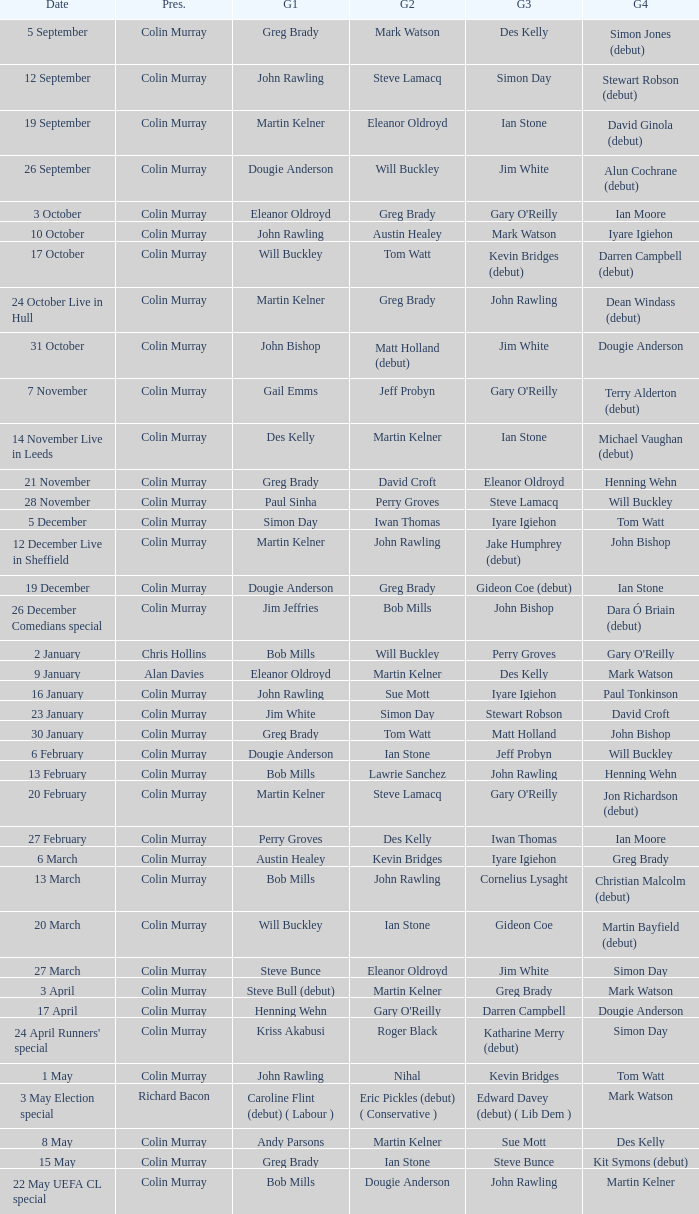How many people are guest 1 on episodes where guest 4 is Des Kelly? 1.0. 